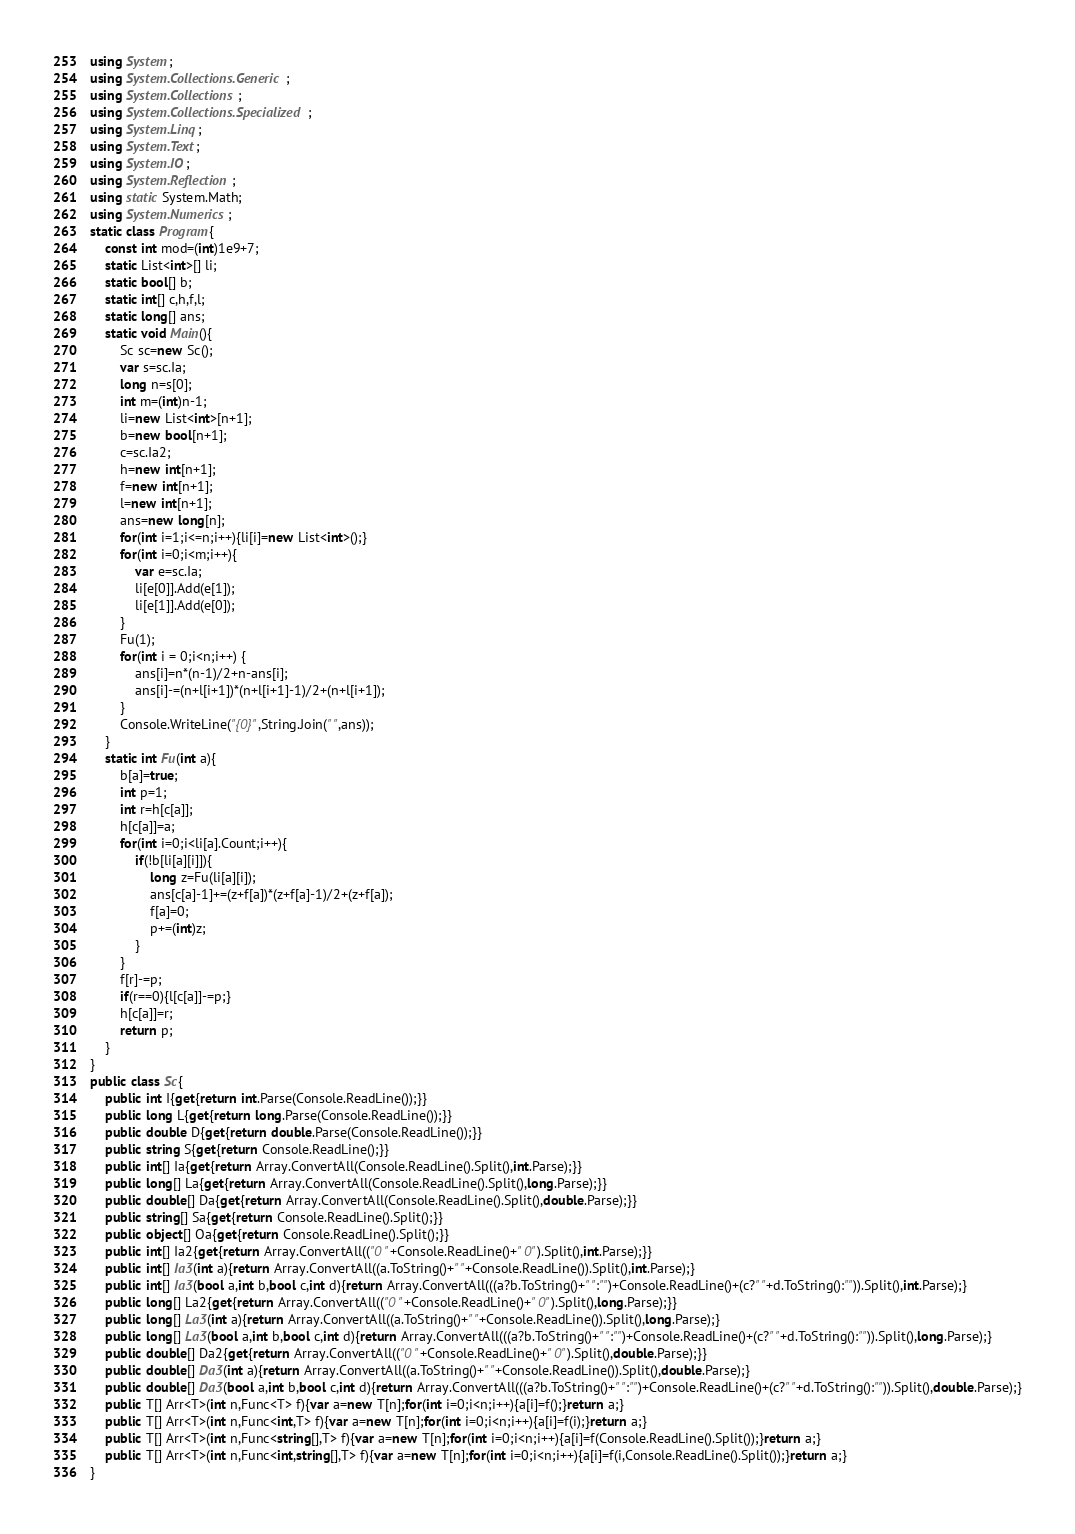Convert code to text. <code><loc_0><loc_0><loc_500><loc_500><_C#_>using System;
using System.Collections.Generic;
using System.Collections;
using System.Collections.Specialized;
using System.Linq;
using System.Text;
using System.IO;
using System.Reflection;
using static System.Math;
using System.Numerics;
static class Program{
	const int mod=(int)1e9+7;
	static List<int>[] li;
	static bool[] b;
	static int[] c,h,f,l;
	static long[] ans;
	static void Main(){
		Sc sc=new Sc();
		var s=sc.Ia;
		long n=s[0];
		int m=(int)n-1;
		li=new List<int>[n+1];
		b=new bool[n+1];
		c=sc.Ia2;
		h=new int[n+1];
		f=new int[n+1];
		l=new int[n+1];
		ans=new long[n];
		for(int i=1;i<=n;i++){li[i]=new List<int>();}
		for(int i=0;i<m;i++){
			var e=sc.Ia;
			li[e[0]].Add(e[1]);
			li[e[1]].Add(e[0]);
		}
		Fu(1);
		for(int i = 0;i<n;i++) {
			ans[i]=n*(n-1)/2+n-ans[i];
			ans[i]-=(n+l[i+1])*(n+l[i+1]-1)/2+(n+l[i+1]);
		}
		Console.WriteLine("{0}",String.Join(" ",ans));
	}
	static int Fu(int a){
		b[a]=true;
		int p=1;
		int r=h[c[a]];
		h[c[a]]=a;
		for(int i=0;i<li[a].Count;i++){
			if(!b[li[a][i]]){
				long z=Fu(li[a][i]);
				ans[c[a]-1]+=(z+f[a])*(z+f[a]-1)/2+(z+f[a]);
				f[a]=0;
				p+=(int)z;
			}
		}
		f[r]-=p;
		if(r==0){l[c[a]]-=p;}
		h[c[a]]=r;
		return p;
	}
}
public class Sc{
	public int I{get{return int.Parse(Console.ReadLine());}}
	public long L{get{return long.Parse(Console.ReadLine());}}
	public double D{get{return double.Parse(Console.ReadLine());}}
	public string S{get{return Console.ReadLine();}}
	public int[] Ia{get{return Array.ConvertAll(Console.ReadLine().Split(),int.Parse);}}
	public long[] La{get{return Array.ConvertAll(Console.ReadLine().Split(),long.Parse);}}
	public double[] Da{get{return Array.ConvertAll(Console.ReadLine().Split(),double.Parse);}}
	public string[] Sa{get{return Console.ReadLine().Split();}}
	public object[] Oa{get{return Console.ReadLine().Split();}}
	public int[] Ia2{get{return Array.ConvertAll(("0 "+Console.ReadLine()+" 0").Split(),int.Parse);}}
	public int[] Ia3(int a){return Array.ConvertAll((a.ToString()+" "+Console.ReadLine()).Split(),int.Parse);}
	public int[] Ia3(bool a,int b,bool c,int d){return Array.ConvertAll(((a?b.ToString()+" ":"")+Console.ReadLine()+(c?" "+d.ToString():"")).Split(),int.Parse);}
	public long[] La2{get{return Array.ConvertAll(("0 "+Console.ReadLine()+" 0").Split(),long.Parse);}}
	public long[] La3(int a){return Array.ConvertAll((a.ToString()+" "+Console.ReadLine()).Split(),long.Parse);}
	public long[] La3(bool a,int b,bool c,int d){return Array.ConvertAll(((a?b.ToString()+" ":"")+Console.ReadLine()+(c?" "+d.ToString():"")).Split(),long.Parse);}
	public double[] Da2{get{return Array.ConvertAll(("0 "+Console.ReadLine()+" 0").Split(),double.Parse);}}
	public double[] Da3(int a){return Array.ConvertAll((a.ToString()+" "+Console.ReadLine()).Split(),double.Parse);}
	public double[] Da3(bool a,int b,bool c,int d){return Array.ConvertAll(((a?b.ToString()+" ":"")+Console.ReadLine()+(c?" "+d.ToString():"")).Split(),double.Parse);}
	public T[] Arr<T>(int n,Func<T> f){var a=new T[n];for(int i=0;i<n;i++){a[i]=f();}return a;}
	public T[] Arr<T>(int n,Func<int,T> f){var a=new T[n];for(int i=0;i<n;i++){a[i]=f(i);}return a;}
	public T[] Arr<T>(int n,Func<string[],T> f){var a=new T[n];for(int i=0;i<n;i++){a[i]=f(Console.ReadLine().Split());}return a;}
	public T[] Arr<T>(int n,Func<int,string[],T> f){var a=new T[n];for(int i=0;i<n;i++){a[i]=f(i,Console.ReadLine().Split());}return a;}
}</code> 